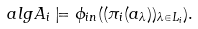Convert formula to latex. <formula><loc_0><loc_0><loc_500><loc_500>\ a l g { A } _ { i } \models \phi _ { i n } ( ( \pi _ { i } ( a _ { \lambda } ) ) _ { \lambda \in L _ { i } } ) .</formula> 